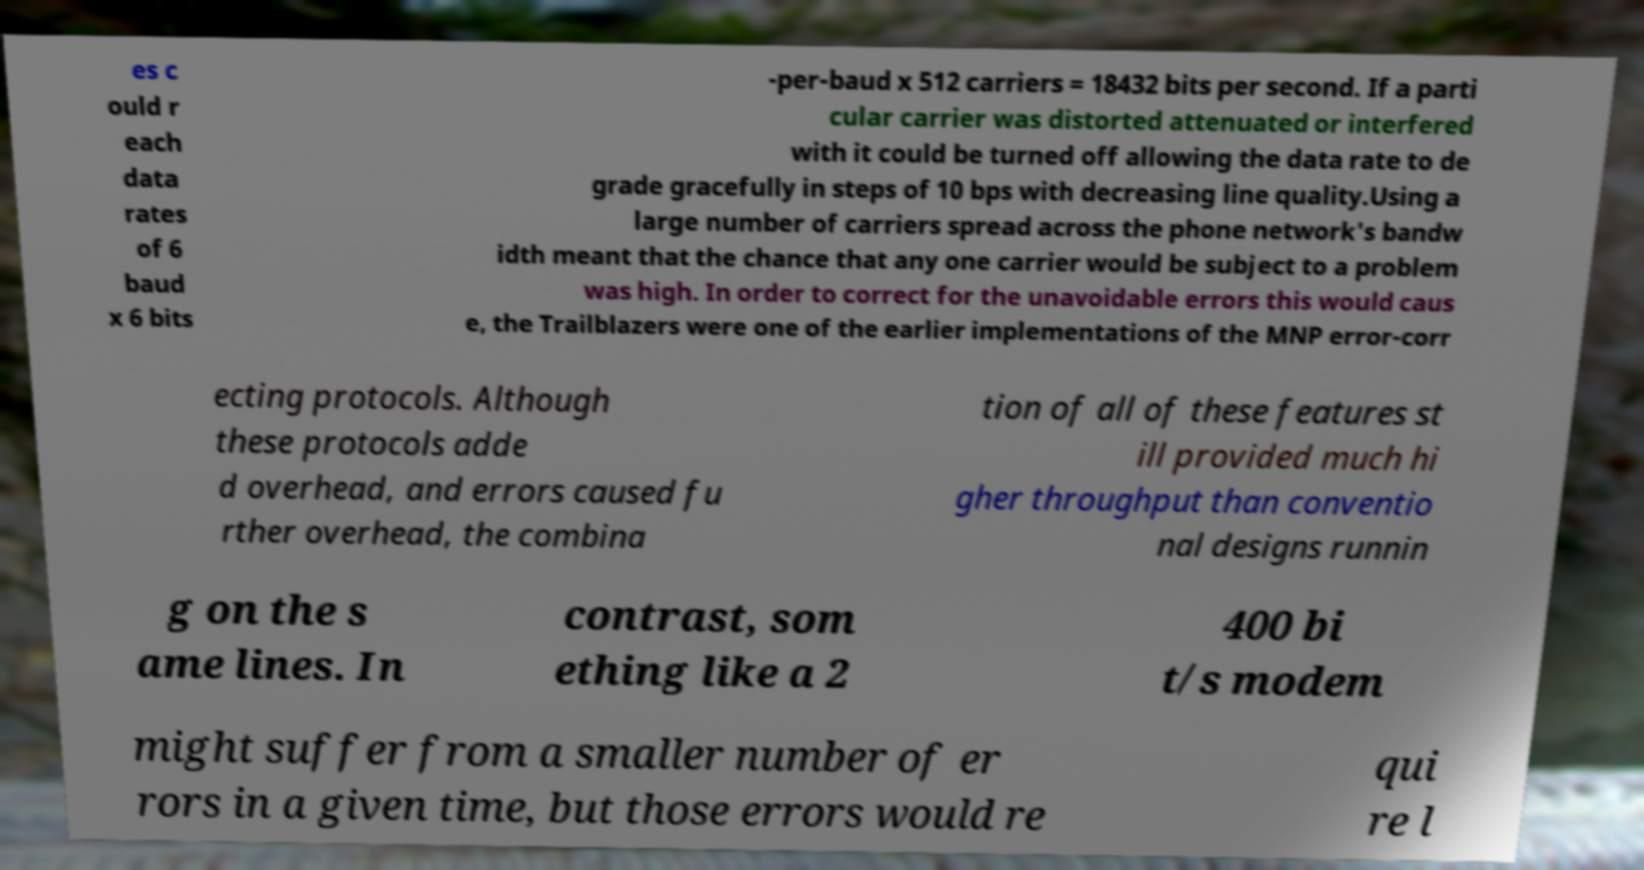For documentation purposes, I need the text within this image transcribed. Could you provide that? es c ould r each data rates of 6 baud x 6 bits -per-baud x 512 carriers = 18432 bits per second. If a parti cular carrier was distorted attenuated or interfered with it could be turned off allowing the data rate to de grade gracefully in steps of 10 bps with decreasing line quality.Using a large number of carriers spread across the phone network's bandw idth meant that the chance that any one carrier would be subject to a problem was high. In order to correct for the unavoidable errors this would caus e, the Trailblazers were one of the earlier implementations of the MNP error-corr ecting protocols. Although these protocols adde d overhead, and errors caused fu rther overhead, the combina tion of all of these features st ill provided much hi gher throughput than conventio nal designs runnin g on the s ame lines. In contrast, som ething like a 2 400 bi t/s modem might suffer from a smaller number of er rors in a given time, but those errors would re qui re l 